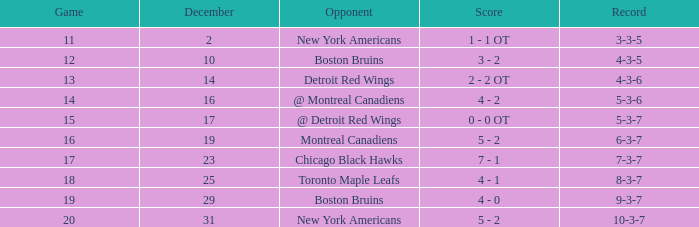In which december is there a record of 4-3-6? 14.0. 